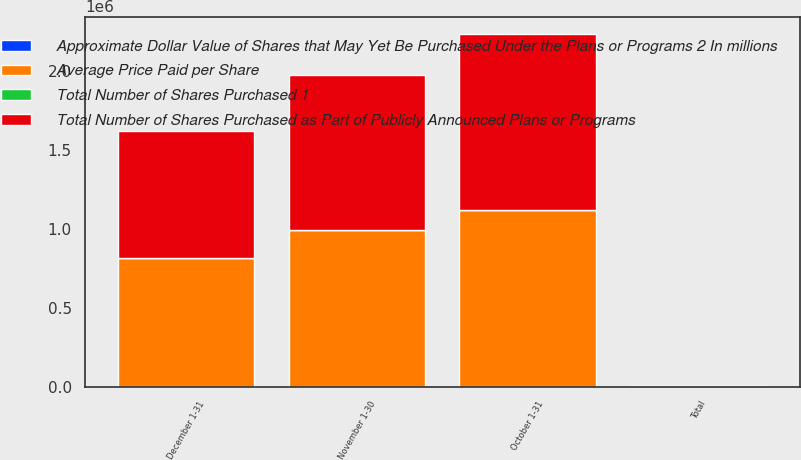Convert chart. <chart><loc_0><loc_0><loc_500><loc_500><stacked_bar_chart><ecel><fcel>October 1-31<fcel>November 1-30<fcel>December 1-31<fcel>Total<nl><fcel>Average Price Paid per Share<fcel>1.11988e+06<fcel>991915<fcel>813256<fcel>851.2<nl><fcel>Approximate Dollar Value of Shares that May Yet Be Purchased Under the Plans or Programs 2 In millions<fcel>50.5<fcel>41.39<fcel>43.34<fcel>45.42<nl><fcel>Total Number of Shares Purchased as Part of Publicly Announced Plans or Programs<fcel>1.1129e+06<fcel>985200<fcel>807300<fcel>851.2<nl><fcel>Total Number of Shares Purchased 1<fcel>871.6<fcel>830.8<fcel>795.8<fcel>795.8<nl></chart> 